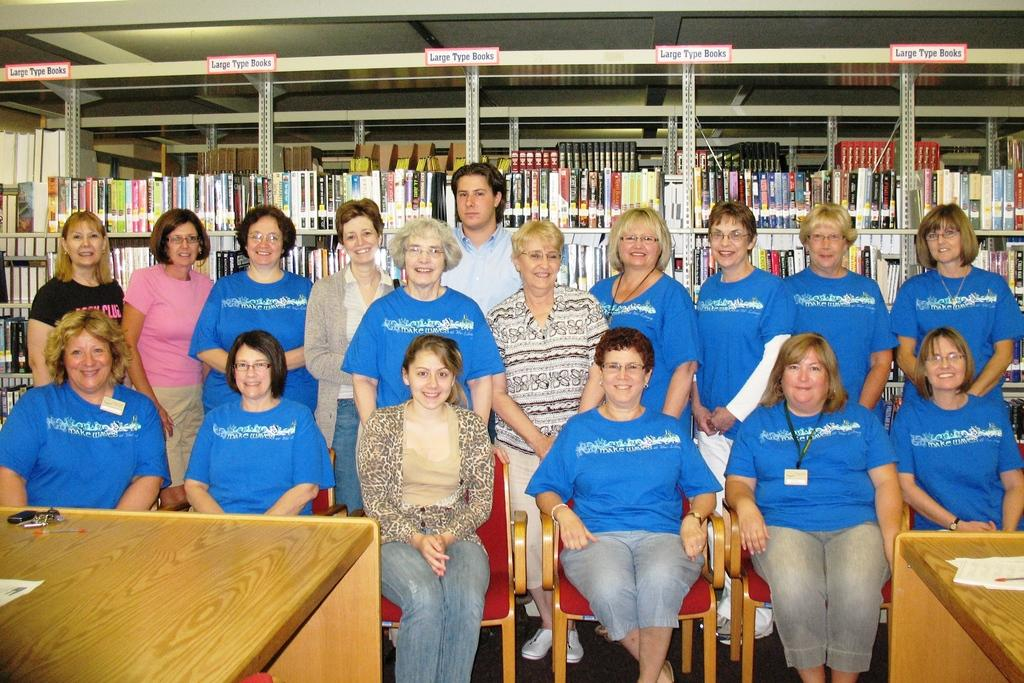What are the women in the image doing? The women in the image are standing. Is there anyone else in the image besides the women? Yes, there is a woman sitting on a chair and a man in the background. What can be seen on the shelf in the background? The shelf in the background is carrying books. What type of canvas is the dad painting in the image? There is no dad or canvas present in the image. What is the man in the background doing with the wheel? There is no wheel present in the image, and the man in the background is not depicted as doing anything with a wheel. 